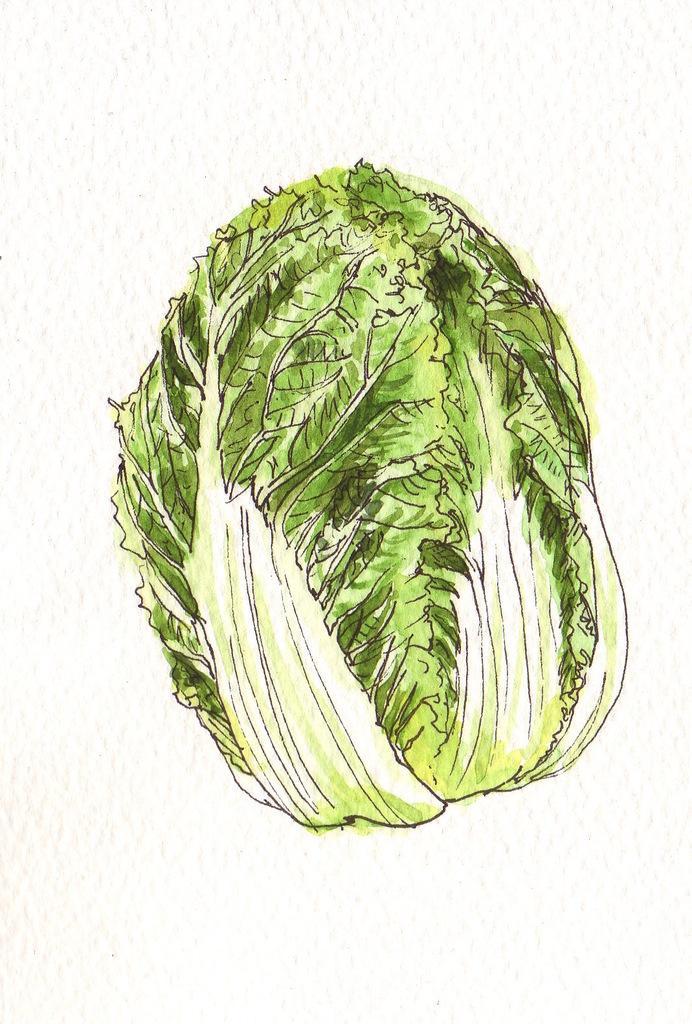Please provide a concise description of this image. This picture contains the cabbage, which is green in color is drawn on the table. In the background, it is white in color. 